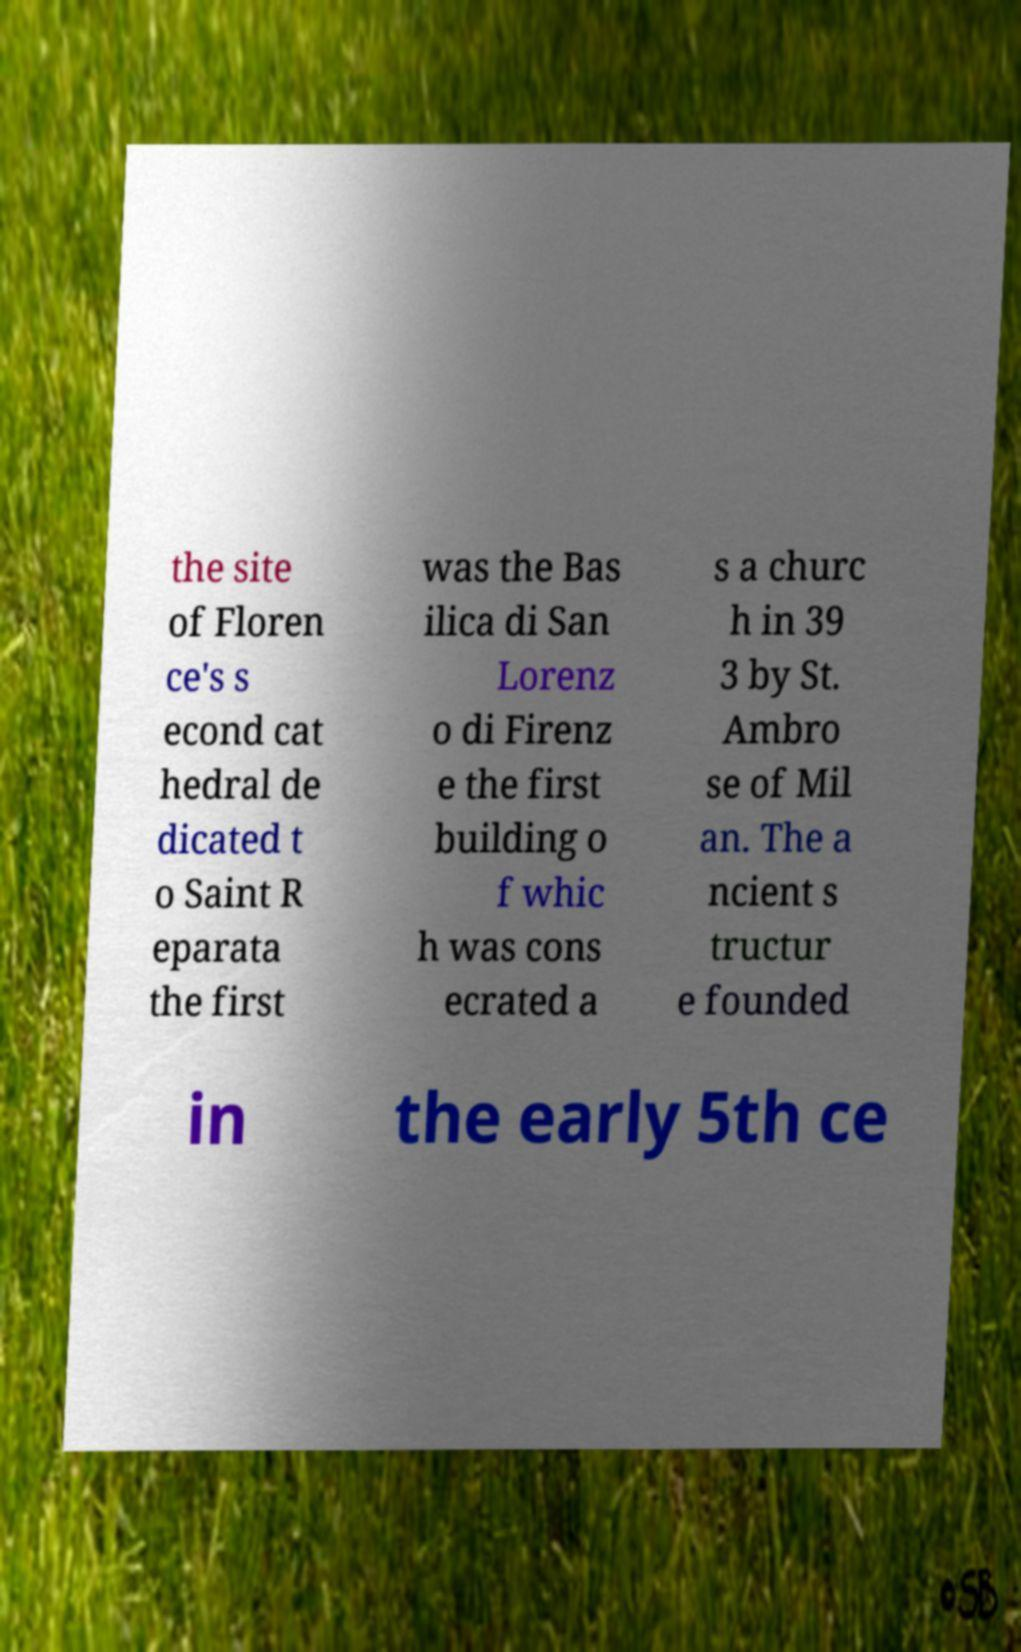What messages or text are displayed in this image? I need them in a readable, typed format. the site of Floren ce's s econd cat hedral de dicated t o Saint R eparata the first was the Bas ilica di San Lorenz o di Firenz e the first building o f whic h was cons ecrated a s a churc h in 39 3 by St. Ambro se of Mil an. The a ncient s tructur e founded in the early 5th ce 